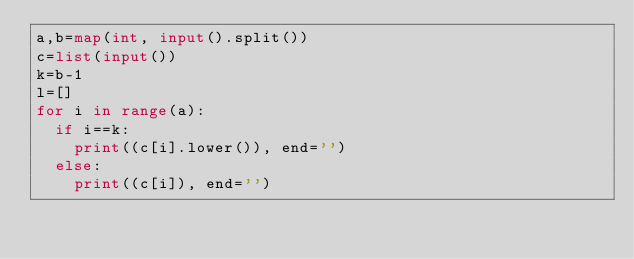Convert code to text. <code><loc_0><loc_0><loc_500><loc_500><_Python_>a,b=map(int, input().split())
c=list(input())
k=b-1
l=[]
for i in range(a):
	if i==k:
		print((c[i].lower()), end='')
	else:
		print((c[i]), end='')
		

</code> 